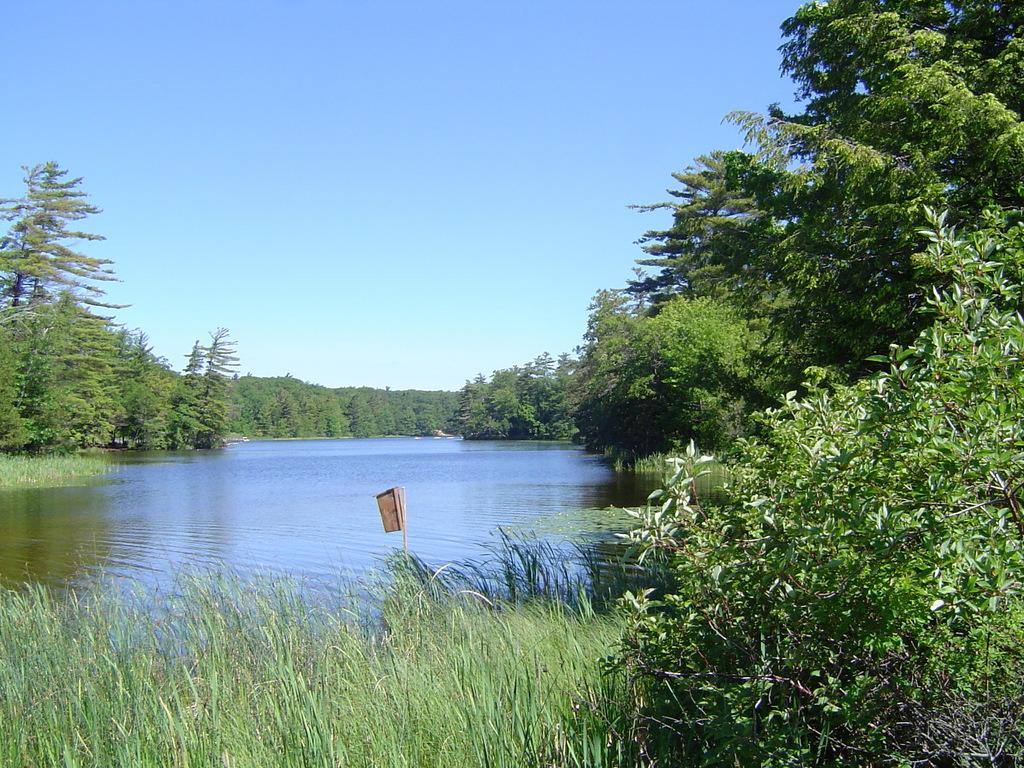What type of natural body of water is present in the image? There is a lake in the image. What type of vegetation can be seen in the image? There are many trees and plants in the image. Can you describe the object in the image? Unfortunately, the facts provided do not give enough information to describe the object in the image. What is visible in the sky in the image? The sky is visible in the image. What degree of difficulty is the arch in the image rated? There is no arch present in the image, so it cannot be rated for difficulty. 